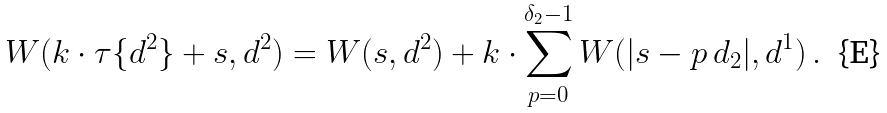<formula> <loc_0><loc_0><loc_500><loc_500>W ( k \cdot \tau \{ { d } ^ { 2 } \} + s , { d } ^ { 2 } ) = W ( s , { d } ^ { 2 } ) + k \cdot \sum _ { p = 0 } ^ { \delta _ { 2 } - 1 } W ( | s - p \, d _ { 2 } | , { d } ^ { 1 } ) \, .</formula> 